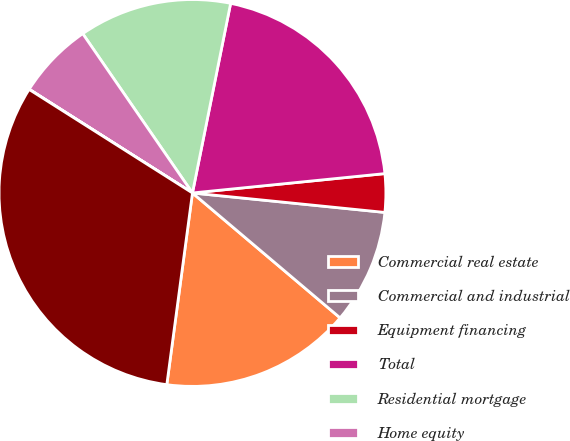Convert chart to OTSL. <chart><loc_0><loc_0><loc_500><loc_500><pie_chart><fcel>Commercial real estate<fcel>Commercial and industrial<fcel>Equipment financing<fcel>Total<fcel>Residential mortgage<fcel>Home equity<fcel>Other consumer<fcel>Total originated loans<nl><fcel>15.94%<fcel>9.57%<fcel>3.2%<fcel>20.24%<fcel>12.76%<fcel>6.39%<fcel>0.02%<fcel>31.87%<nl></chart> 